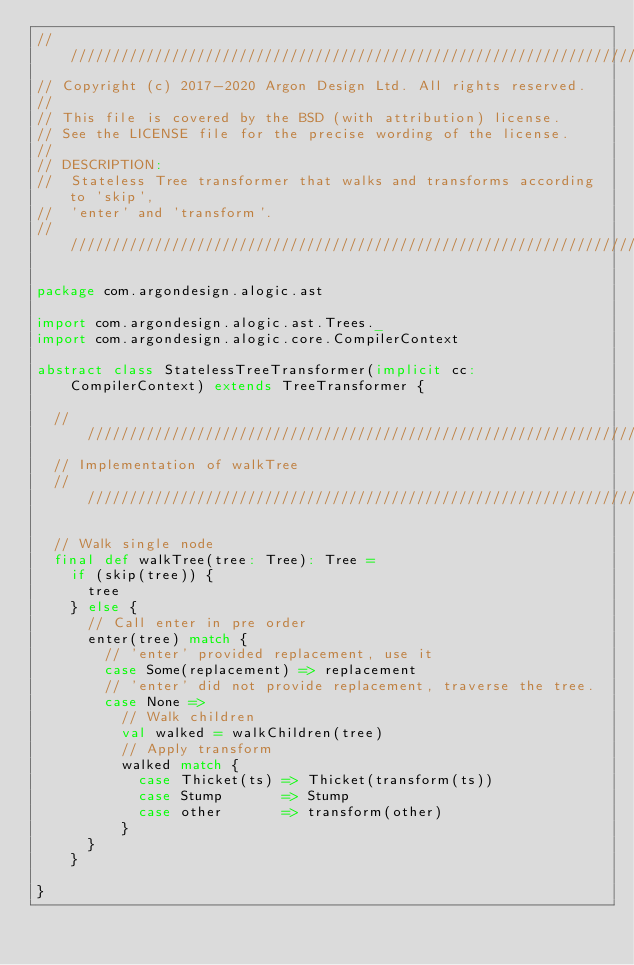<code> <loc_0><loc_0><loc_500><loc_500><_Scala_>////////////////////////////////////////////////////////////////////////////////
// Copyright (c) 2017-2020 Argon Design Ltd. All rights reserved.
//
// This file is covered by the BSD (with attribution) license.
// See the LICENSE file for the precise wording of the license.
//
// DESCRIPTION:
//  Stateless Tree transformer that walks and transforms according to 'skip',
//  'enter' and 'transform'.
////////////////////////////////////////////////////////////////////////////////

package com.argondesign.alogic.ast

import com.argondesign.alogic.ast.Trees._
import com.argondesign.alogic.core.CompilerContext

abstract class StatelessTreeTransformer(implicit cc: CompilerContext) extends TreeTransformer {

  //////////////////////////////////////////////////////////////////////////////
  // Implementation of walkTree
  //////////////////////////////////////////////////////////////////////////////

  // Walk single node
  final def walkTree(tree: Tree): Tree =
    if (skip(tree)) {
      tree
    } else {
      // Call enter in pre order
      enter(tree) match {
        // 'enter' provided replacement, use it
        case Some(replacement) => replacement
        // 'enter' did not provide replacement, traverse the tree.
        case None =>
          // Walk children
          val walked = walkChildren(tree)
          // Apply transform
          walked match {
            case Thicket(ts) => Thicket(transform(ts))
            case Stump       => Stump
            case other       => transform(other)
          }
      }
    }

}
</code> 